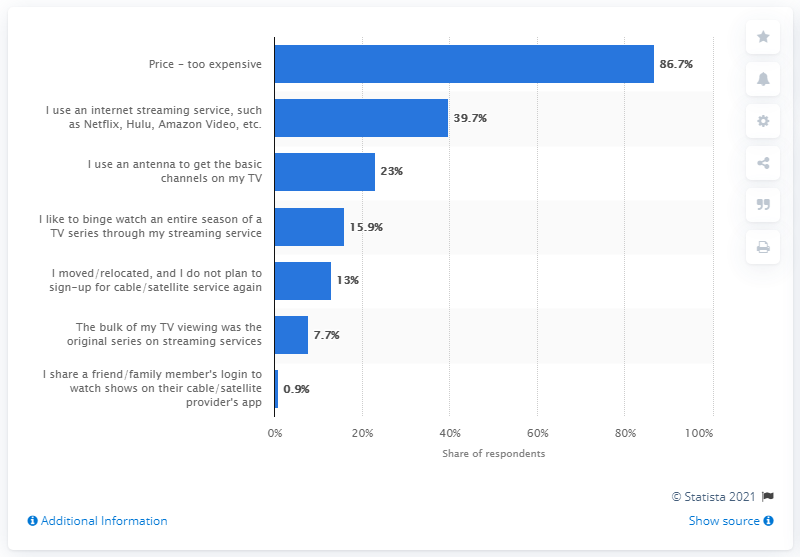Give some essential details in this illustration. According to the data, 86.7% of respondents reported having canceled their cable or satellite service due to its high cost. 